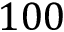<formula> <loc_0><loc_0><loc_500><loc_500>1 0 0</formula> 